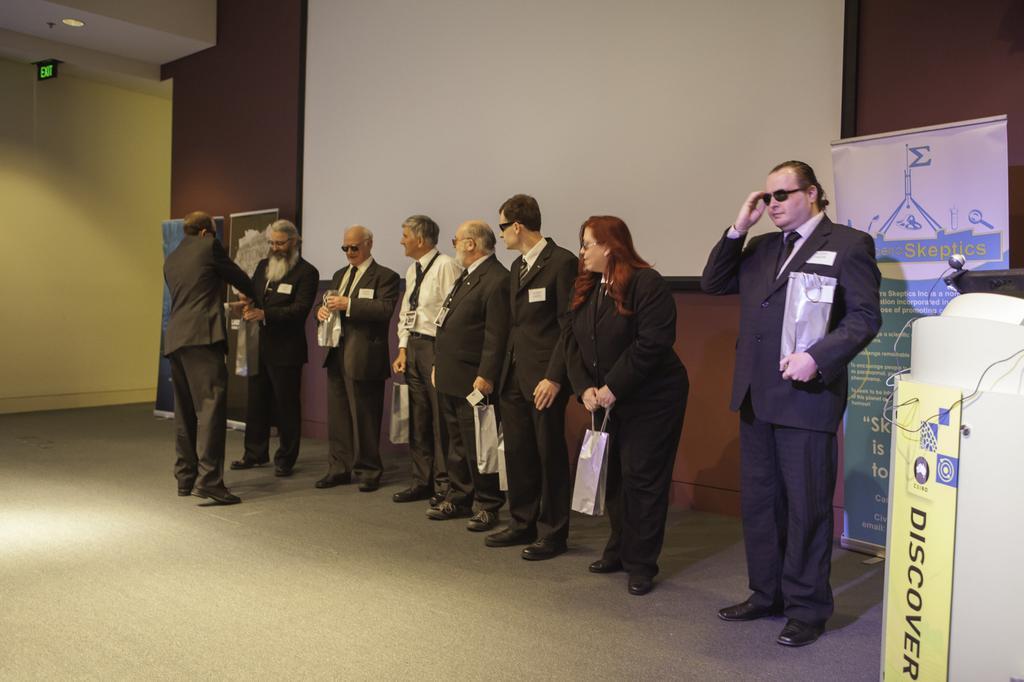Could you give a brief overview of what you see in this image? In this image there are a group of people standing on the stage behind them there are some banners. 